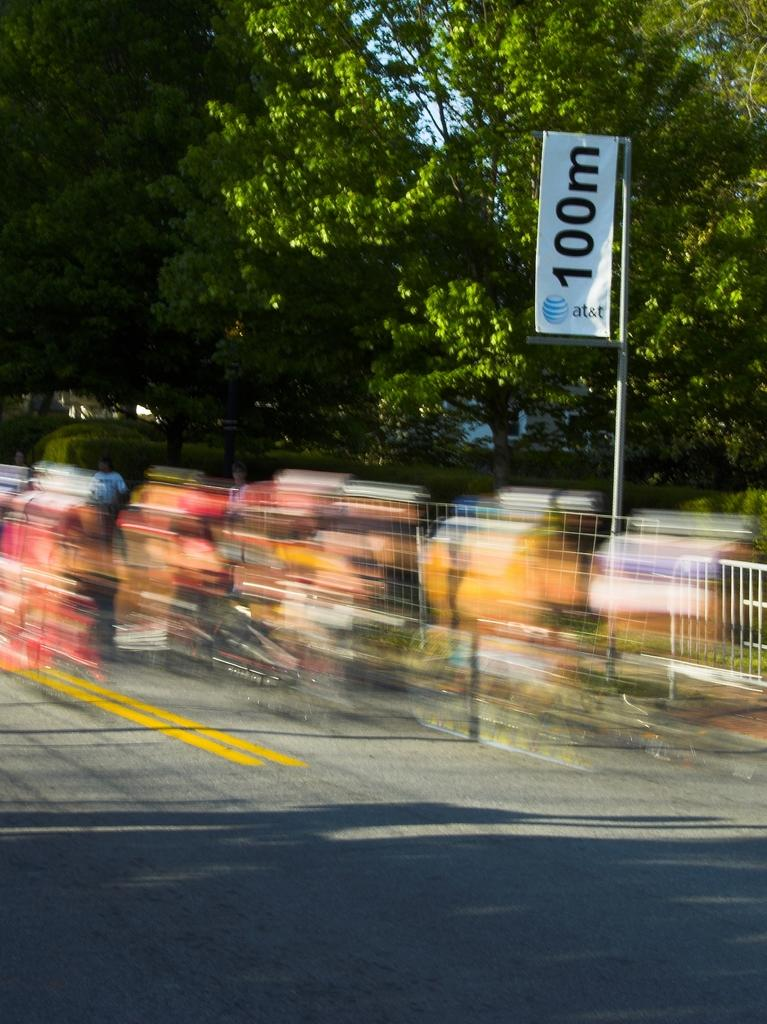What type of natural elements can be seen in the image? There are trees in the image. What architectural feature is present in the image? There are railings in the image. What is written or displayed on the board in the image? There is a board with text and numbers in the image. How many people are visible in the image? There are people in the image. What type of man-made structure is present in the image? There is a road in the image. Are there any parts of the image that are difficult to see clearly? Some parts of the image are blurred. Can you tell me how much salt is being used by the girl in the image? There is no girl or salt present in the image. What is causing the burn in the image? There is no burn present in the image. 